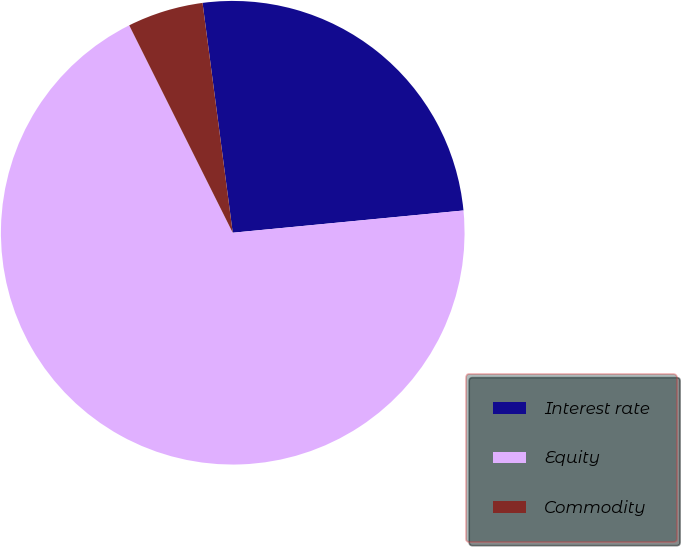Convert chart to OTSL. <chart><loc_0><loc_0><loc_500><loc_500><pie_chart><fcel>Interest rate<fcel>Equity<fcel>Commodity<nl><fcel>25.55%<fcel>69.16%<fcel>5.29%<nl></chart> 